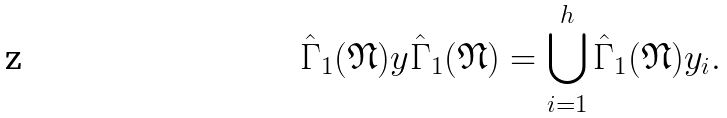Convert formula to latex. <formula><loc_0><loc_0><loc_500><loc_500>\hat { \Gamma } _ { 1 } ( \mathfrak { N } ) y \hat { \Gamma } _ { 1 } ( \mathfrak { N } ) = \bigcup _ { i = 1 } ^ { h } \hat { \Gamma } _ { 1 } ( \mathfrak { N } ) y _ { i } .</formula> 